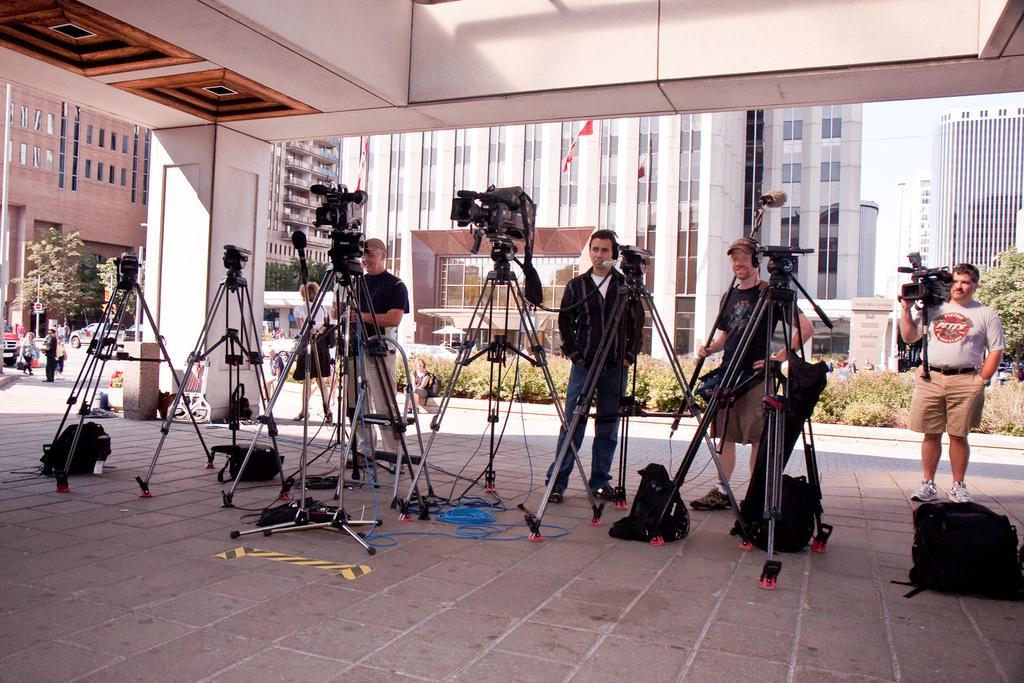How would you summarize this image in a sentence or two? In this image I can see group of people standing and I can also see few cameras, background I can see a person is wearing white shirt, cream short and holding a camera and I can also see few black color bags on the floor. Background I can see trees in green color, few vehicles, buildings in white, brown and cream color and the sky is in white color. 